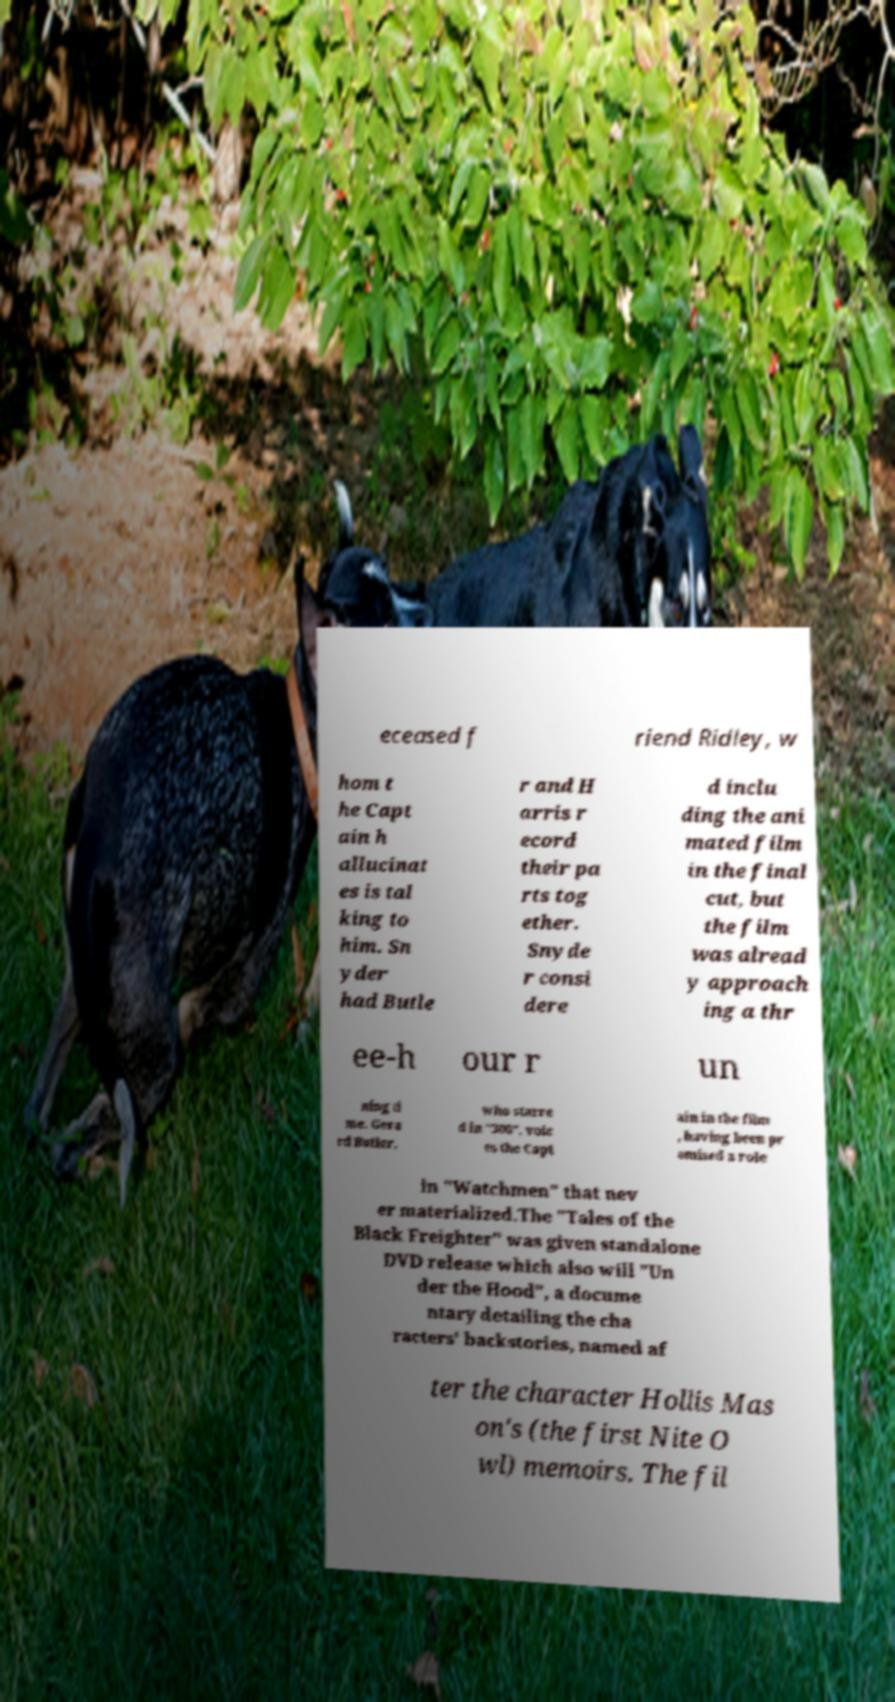There's text embedded in this image that I need extracted. Can you transcribe it verbatim? eceased f riend Ridley, w hom t he Capt ain h allucinat es is tal king to him. Sn yder had Butle r and H arris r ecord their pa rts tog ether. Snyde r consi dere d inclu ding the ani mated film in the final cut, but the film was alread y approach ing a thr ee-h our r un ning ti me. Gera rd Butler, who starre d in "300", voic es the Capt ain in the film , having been pr omised a role in "Watchmen" that nev er materialized.The "Tales of the Black Freighter" was given standalone DVD release which also will "Un der the Hood", a docume ntary detailing the cha racters' backstories, named af ter the character Hollis Mas on's (the first Nite O wl) memoirs. The fil 